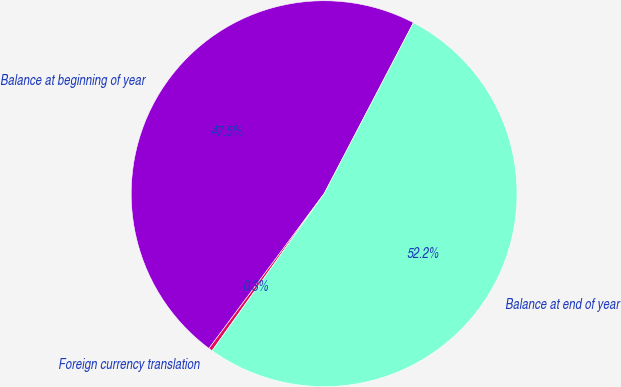<chart> <loc_0><loc_0><loc_500><loc_500><pie_chart><fcel>Balance at beginning of year<fcel>Foreign currency translation<fcel>Balance at end of year<nl><fcel>47.48%<fcel>0.32%<fcel>52.2%<nl></chart> 